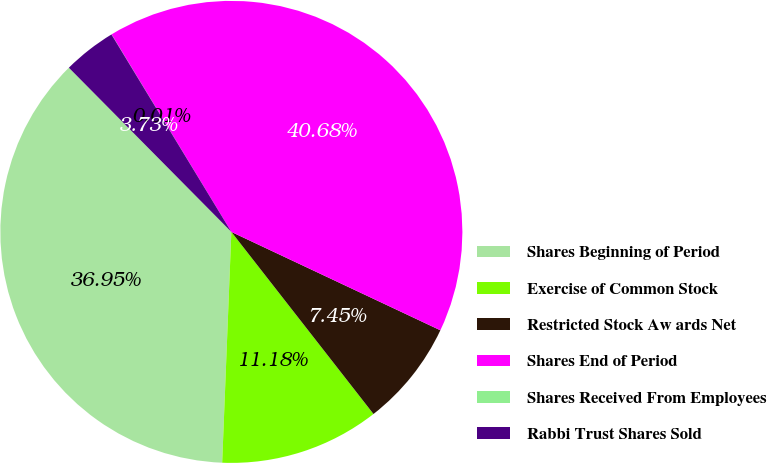<chart> <loc_0><loc_0><loc_500><loc_500><pie_chart><fcel>Shares Beginning of Period<fcel>Exercise of Common Stock<fcel>Restricted Stock Aw ards Net<fcel>Shares End of Period<fcel>Shares Received From Employees<fcel>Rabbi Trust Shares Sold<nl><fcel>36.95%<fcel>11.18%<fcel>7.45%<fcel>40.68%<fcel>0.01%<fcel>3.73%<nl></chart> 